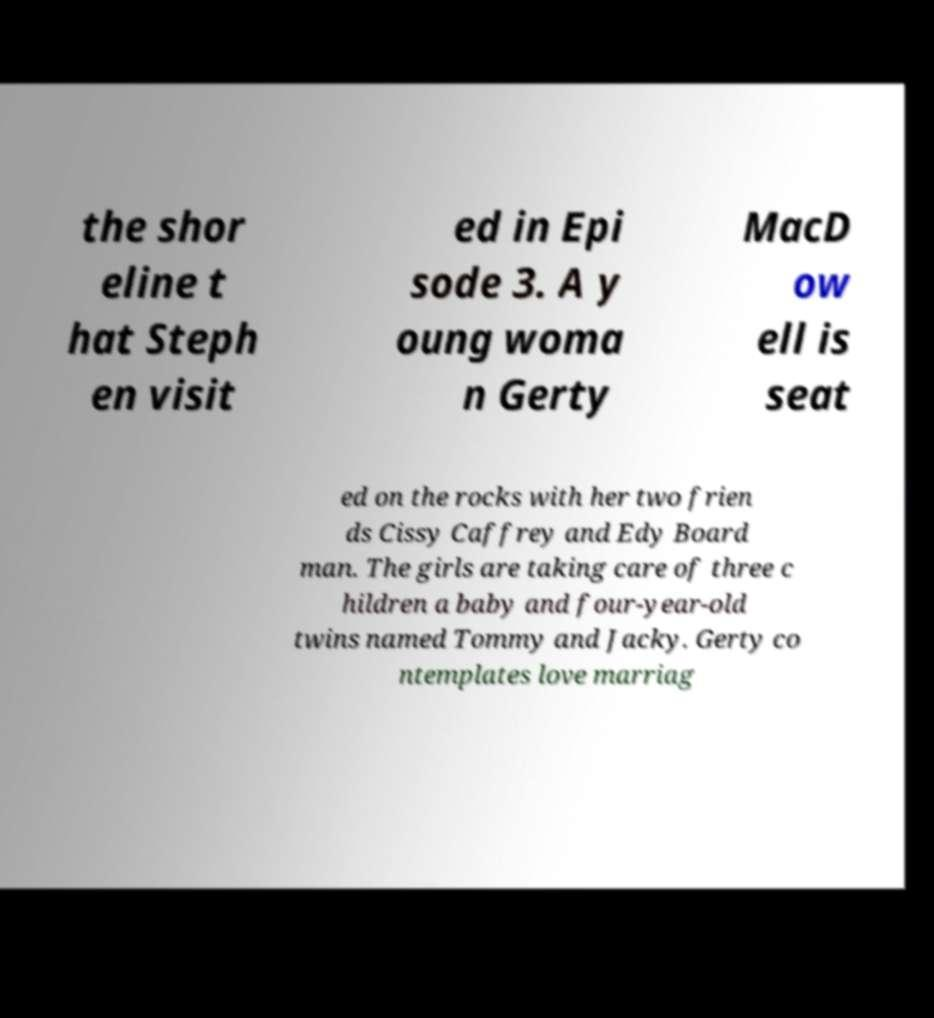Could you extract and type out the text from this image? the shor eline t hat Steph en visit ed in Epi sode 3. A y oung woma n Gerty MacD ow ell is seat ed on the rocks with her two frien ds Cissy Caffrey and Edy Board man. The girls are taking care of three c hildren a baby and four-year-old twins named Tommy and Jacky. Gerty co ntemplates love marriag 